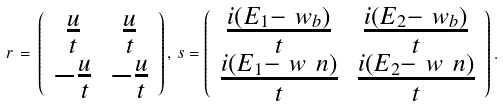<formula> <loc_0><loc_0><loc_500><loc_500>r \, = \, \left ( \begin{array} { c c } \frac { u } { t } & \frac { u } { t } \\ - \frac { u } { t } & - \frac { u } { t } \end{array} \right ) , \, s = \left ( \begin{array} { c c } \frac { i ( E _ { 1 } - \ w _ { b } ) } { t } & \frac { i ( E _ { 2 } - \ w _ { b } ) } { t } \\ \frac { i ( E _ { 1 } - \ w _ { \ } n ) } { t } & \frac { i ( E _ { 2 } - \ w _ { \ } n ) } { t } \end{array} \right ) .</formula> 